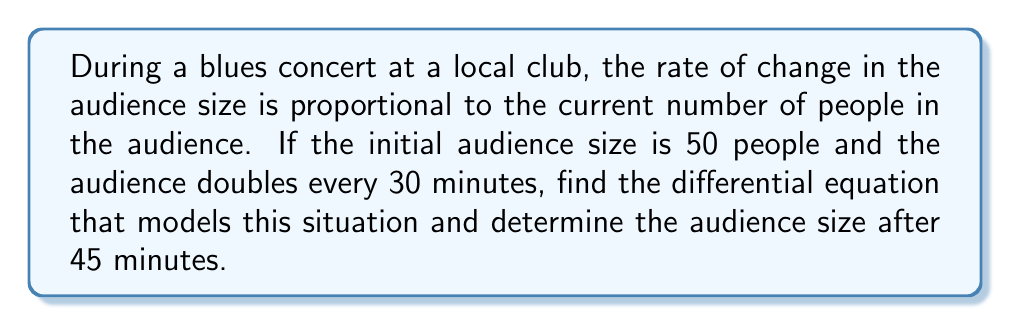Solve this math problem. Let's approach this step-by-step:

1) Let $A(t)$ be the audience size at time $t$ (in minutes).

2) We're told that the rate of change is proportional to the current audience size. This can be expressed as:

   $$\frac{dA}{dt} = kA$$

   where $k$ is the proportionality constant.

3) We're given that the audience doubles every 30 minutes. We can use this to find $k$:

   At $t=0$, $A(0) = 50$
   At $t=30$, $A(30) = 100$

   Using the solution to the differential equation: $A(t) = A(0)e^{kt}$

   $100 = 50e^{30k}$
   $2 = e^{30k}$
   $\ln(2) = 30k$
   $k = \frac{\ln(2)}{30} \approx 0.0231$ per minute

4) Now we have our complete differential equation:

   $$\frac{dA}{dt} = \frac{\ln(2)}{30}A$$

5) To find the audience size after 45 minutes, we use the solution:

   $A(t) = A(0)e^{kt} = 50e^{\frac{\ln(2)}{30}t}$

   Plugging in $t=45$:

   $A(45) = 50e^{\frac{\ln(2)}{30}(45)} = 50e^{\frac{3\ln(2)}{2}} = 50(2^{\frac{3}{2}}) \approx 141.4$
Answer: The differential equation is $\frac{dA}{dt} = \frac{\ln(2)}{30}A$, and the audience size after 45 minutes is approximately 141 people. 